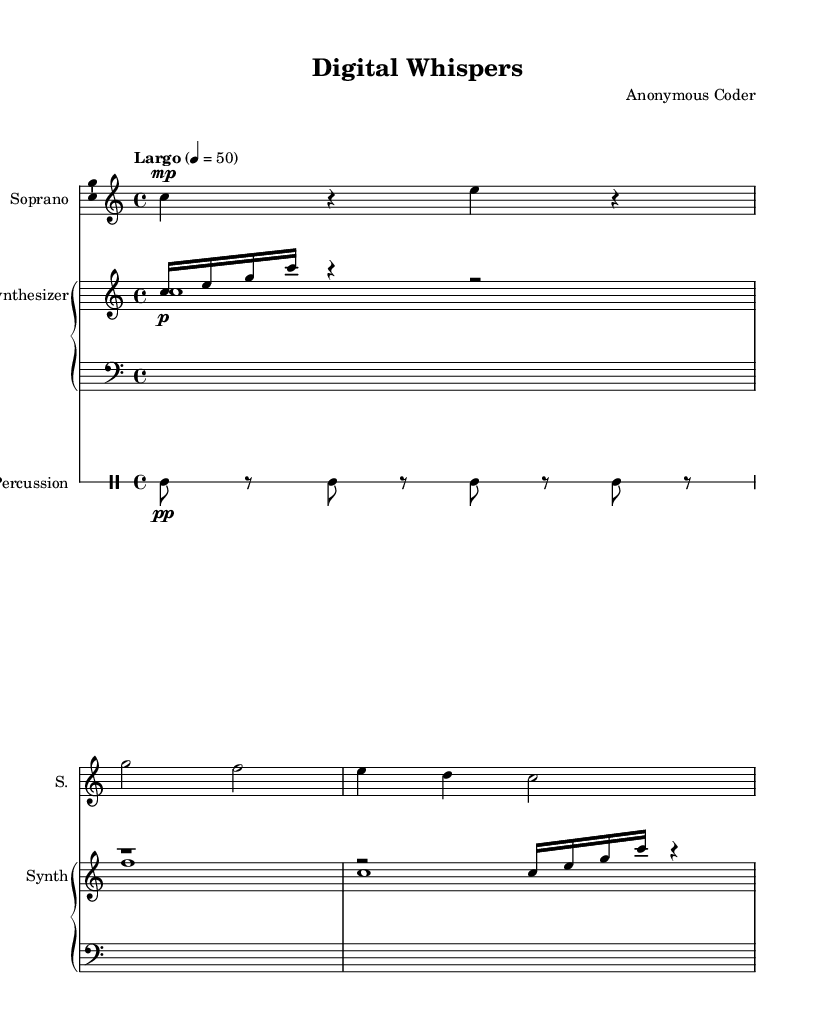What is the key signature of this music? The key signature is written at the beginning of the score, and it indicates that there are no sharps or flats, confirming that it is in C major.
Answer: C major What is the time signature of this piece? The time signature appears at the beginning of the score and is expressed as 4/4, meaning there are four beats in each measure.
Answer: 4/4 What is the tempo marking for this composition? The tempo marking in the score indicates "Largo," which defines the speed of the piece as slow, specifically noted at a quarter note equals fifty beats per minute.
Answer: Largo How many measures are in the soprano part? By counting the measures in the soprano staff, there are a total of three measures present in the provided music.
Answer: Three What is the dynamic marking of the synthesizer voice? The dynamic marking is found directly on the synthesizer staff and is indicated as "p," which stands for piano, meaning soft.
Answer: Piano What is the function of the electronic percussion in this opera piece? The electronic percussion adds rhythmic texture throughout the piece, providing a modern feel alongside the minimalist composition and helping to define the overall avant-garde character of the opera.
Answer: Rhythmic What are the lyrics associated with the soprano part? The lyrics can be found beneath the soprano staff, and they express the phrase "Binary dreams, silicon streams," which complements the electronic theme of the piece.
Answer: Binary dreams, silicon streams 